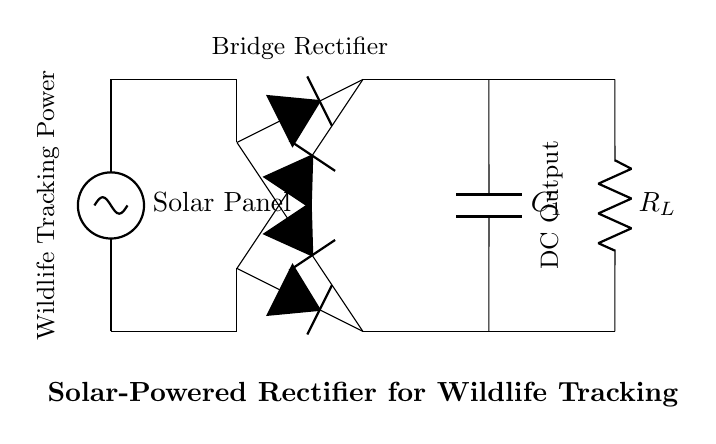What is the main power source in this circuit? The main power source is the solar panel, which converts sunlight into electrical energy.
Answer: Solar Panel How many diodes are used in the bridge rectifier? A bridge rectifier typically consists of four diodes, arranged in a bridge configuration to convert AC to DC.
Answer: Four diodes What is the function of capacitor C1? The capacitor C1 is used to smooth the output voltage by filtering out fluctuations, providing a more stable DC voltage to the load.
Answer: Smoothing What type of load does this circuit support? The circuit supports a resistive load, indicated by the resistor labeled R_L, which represents the device being powered.
Answer: Resistive load What is the purpose of the bridge rectifier? The bridge rectifier's purpose is to convert the alternating current generated by the solar panel into direct current suitable for powering devices.
Answer: Convert AC to DC How is the solar panel connected to the bridge rectifier? The solar panel is directly connected to the input terminals of the bridge rectifier, allowing the generated electricity to flow into it.
Answer: Directly connected What does the label "DC Output" signify in this circuit? The label "DC Output" indicates the output terminal of the circuit where the stabilized direct current is supplied for the wildlife tracking devices.
Answer: Stabilized direct current 